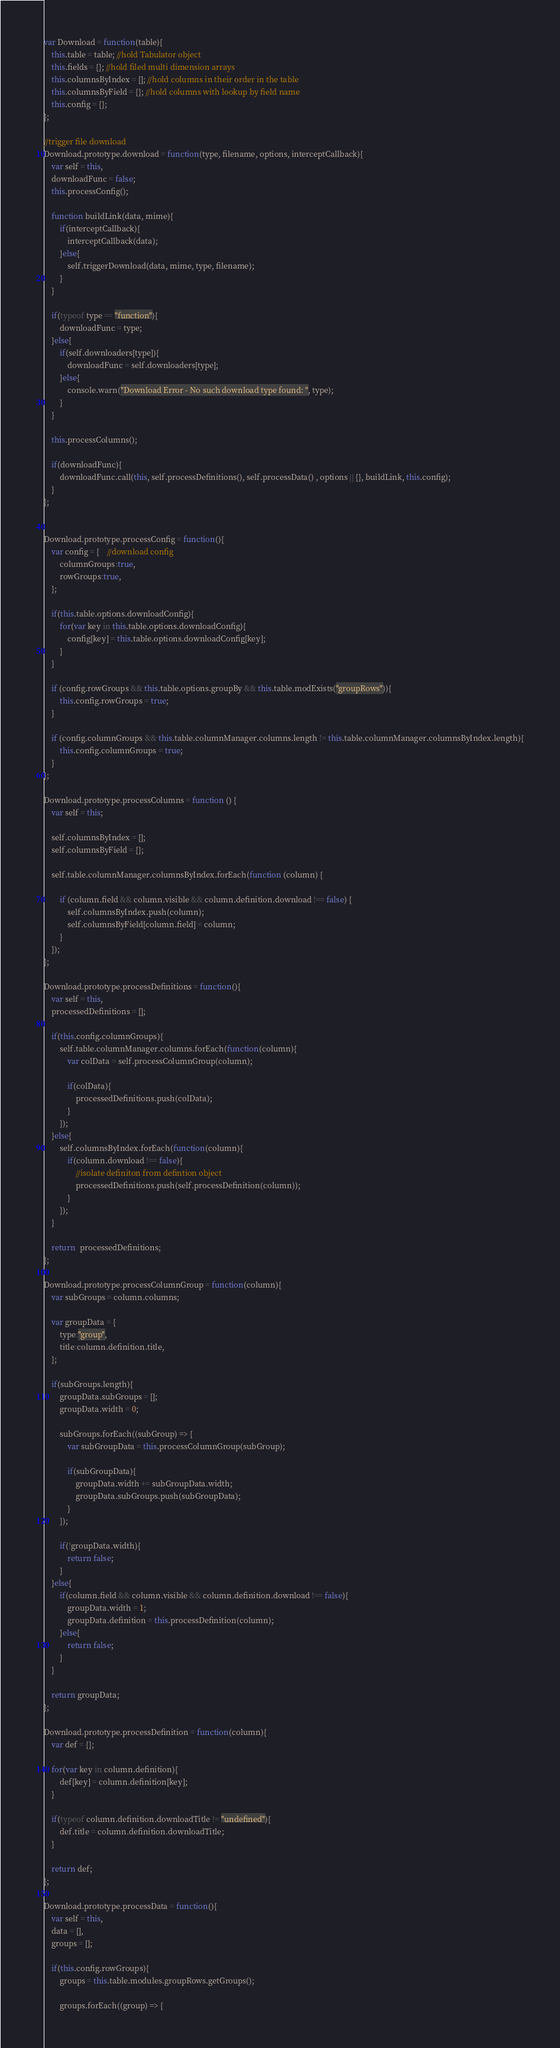Convert code to text. <code><loc_0><loc_0><loc_500><loc_500><_JavaScript_>var Download = function(table){
	this.table = table; //hold Tabulator object
	this.fields = {}; //hold filed multi dimension arrays
	this.columnsByIndex = []; //hold columns in their order in the table
	this.columnsByField = {}; //hold columns with lookup by field name
	this.config = {};
};

//trigger file download
Download.prototype.download = function(type, filename, options, interceptCallback){
	var self = this,
	downloadFunc = false;
	this.processConfig();

	function buildLink(data, mime){
		if(interceptCallback){
			interceptCallback(data);
		}else{
			self.triggerDownload(data, mime, type, filename);
		}
	}

	if(typeof type == "function"){
		downloadFunc = type;
	}else{
		if(self.downloaders[type]){
			downloadFunc = self.downloaders[type];
		}else{
			console.warn("Download Error - No such download type found: ", type);
		}
	}

	this.processColumns();

	if(downloadFunc){
		downloadFunc.call(this, self.processDefinitions(), self.processData() , options || {}, buildLink, this.config);
	}
};


Download.prototype.processConfig = function(){
	var config = {	//download config
		columnGroups:true,
		rowGroups:true,
	};

	if(this.table.options.downloadConfig){
		for(var key in this.table.options.downloadConfig){
			config[key] = this.table.options.downloadConfig[key];
		}
	}

	if (config.rowGroups && this.table.options.groupBy && this.table.modExists("groupRows")){
		this.config.rowGroups = true;
	}

	if (config.columnGroups && this.table.columnManager.columns.length != this.table.columnManager.columnsByIndex.length){
		this.config.columnGroups = true;
	}
};

Download.prototype.processColumns = function () {
	var self = this;

	self.columnsByIndex = [];
	self.columnsByField = {};

	self.table.columnManager.columnsByIndex.forEach(function (column) {

		if (column.field && column.visible && column.definition.download !== false) {
			self.columnsByIndex.push(column);
			self.columnsByField[column.field] = column;
		}
	});
};

Download.prototype.processDefinitions = function(){
	var self = this,
	processedDefinitions = [];

	if(this.config.columnGroups){
		self.table.columnManager.columns.forEach(function(column){
			var colData = self.processColumnGroup(column);

			if(colData){
				processedDefinitions.push(colData);
			}
		});
	}else{
		self.columnsByIndex.forEach(function(column){
			if(column.download !== false){
				//isolate definiton from defintion object
				processedDefinitions.push(self.processDefinition(column));
			}
		});
	}

	return  processedDefinitions;
};

Download.prototype.processColumnGroup = function(column){
	var subGroups = column.columns;

	var groupData = {
		type:"group",
		title:column.definition.title,
	};

	if(subGroups.length){
		groupData.subGroups = [];
		groupData.width = 0;

		subGroups.forEach((subGroup) => {
			var subGroupData = this.processColumnGroup(subGroup);

			if(subGroupData){
				groupData.width += subGroupData.width;
				groupData.subGroups.push(subGroupData);
			}
		});

		if(!groupData.width){
			return false;
		}
	}else{
		if(column.field && column.visible && column.definition.download !== false){
			groupData.width = 1;
			groupData.definition = this.processDefinition(column);
		}else{
			return false;
		}
	}

	return groupData;
};

Download.prototype.processDefinition = function(column){
	var def = {};

	for(var key in column.definition){
		def[key] = column.definition[key];
	}

	if(typeof column.definition.downloadTitle != "undefined"){
		def.title = column.definition.downloadTitle;
	}

	return def;
};

Download.prototype.processData = function(){
	var self = this,
	data = [],
	groups = [];

	if(this.config.rowGroups){
		groups = this.table.modules.groupRows.getGroups();

		groups.forEach((group) => {</code> 